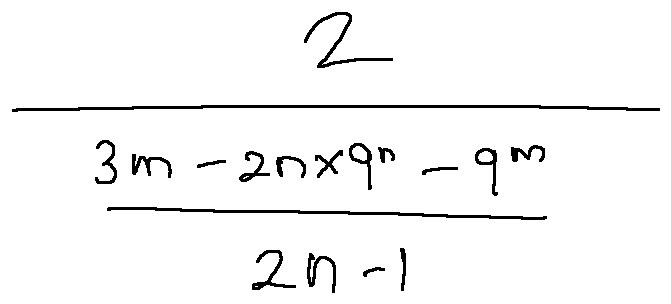Convert formula to latex. <formula><loc_0><loc_0><loc_500><loc_500>\frac { 2 } { \frac { 3 m - 2 n \times 9 ^ { n } - 9 ^ { m } } { 2 n - 1 } }</formula> 